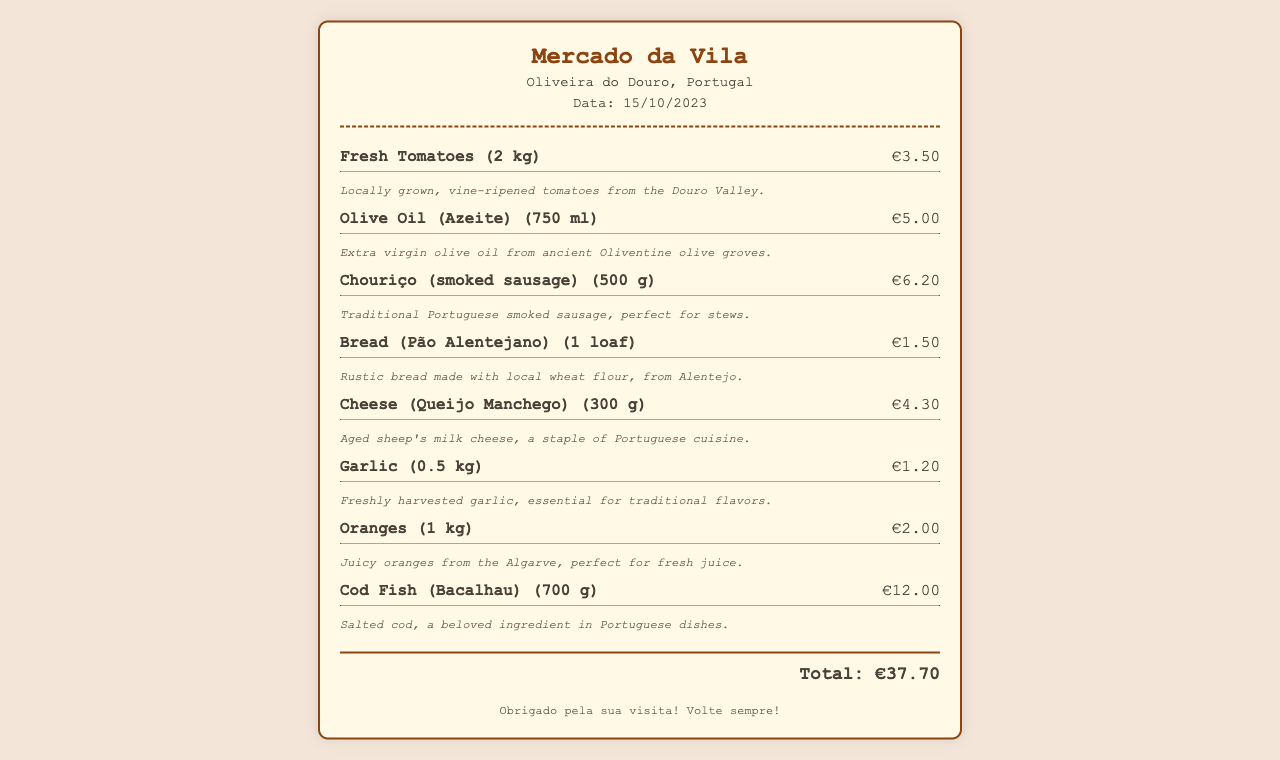What is the date of the receipt? The date of the receipt is specified in the document under the information section.
Answer: 15/10/2023 What is the total amount spent? The total amount is found at the bottom of the receipt in the total section.
Answer: €37.70 What type of bread was purchased? The item name in the receipt specifies the type of bread purchased.
Answer: Pão Alentejano How much does the garlic cost? The cost of the garlic is indicated next to the item in the receipt.
Answer: €1.20 What region are the oranges from? The description of the oranges mentions their origin, indicating a specific region.
Answer: Algarve What ingredient is traditional for Portuguese stews? The item description highlights the traditional use of a specific ingredient in stews.
Answer: Chouriço How many kilograms of cod fish were purchased? The quantity of cod fish is noted in the item name within the receipt.
Answer: 700 g Which ingredient is described as essential for traditional flavors? The item description for garlic emphasizes its importance in traditional cuisine.
Answer: Garlic What is the price of the cheese? The price of cheese is provided next to the item's name on the receipt.
Answer: €4.30 